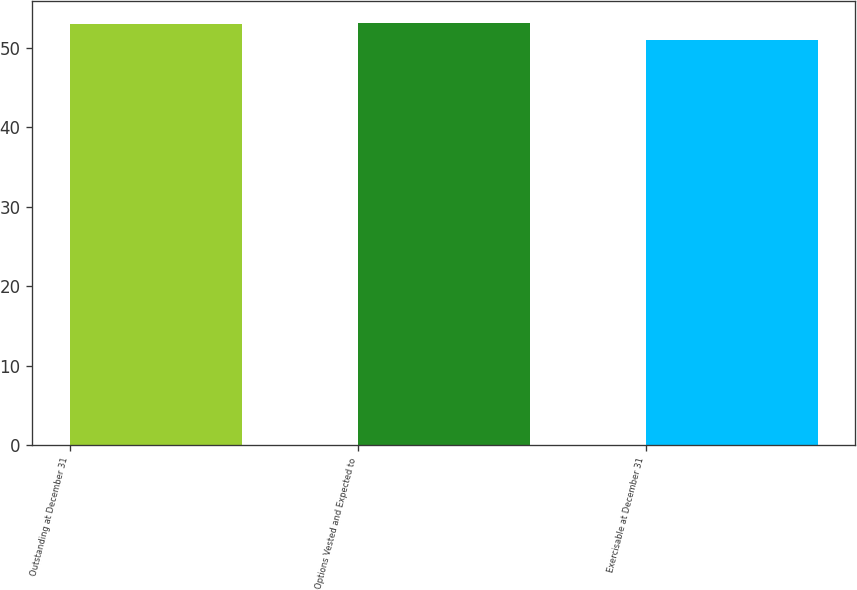<chart> <loc_0><loc_0><loc_500><loc_500><bar_chart><fcel>Outstanding at December 31<fcel>Options Vested and Expected to<fcel>Exercisable at December 31<nl><fcel>53<fcel>53.2<fcel>51<nl></chart> 